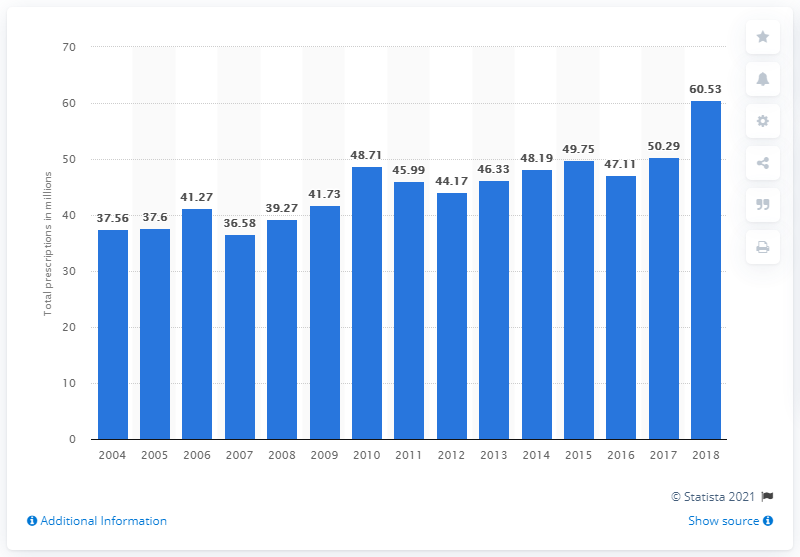Specify some key components in this picture. There were 60.53 prescriptions for albuterol in 2018. 